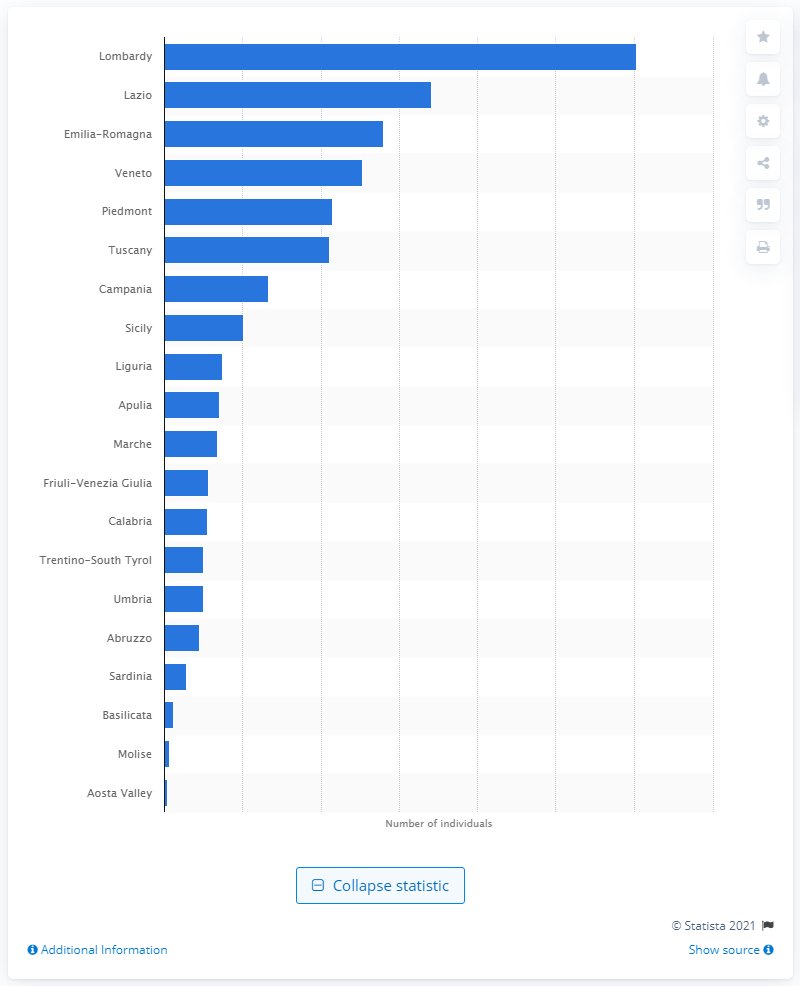List a handful of essential elements in this visual. As of the current estimate, a total of 12,060,231 individuals reside within the region of Lombardy. 